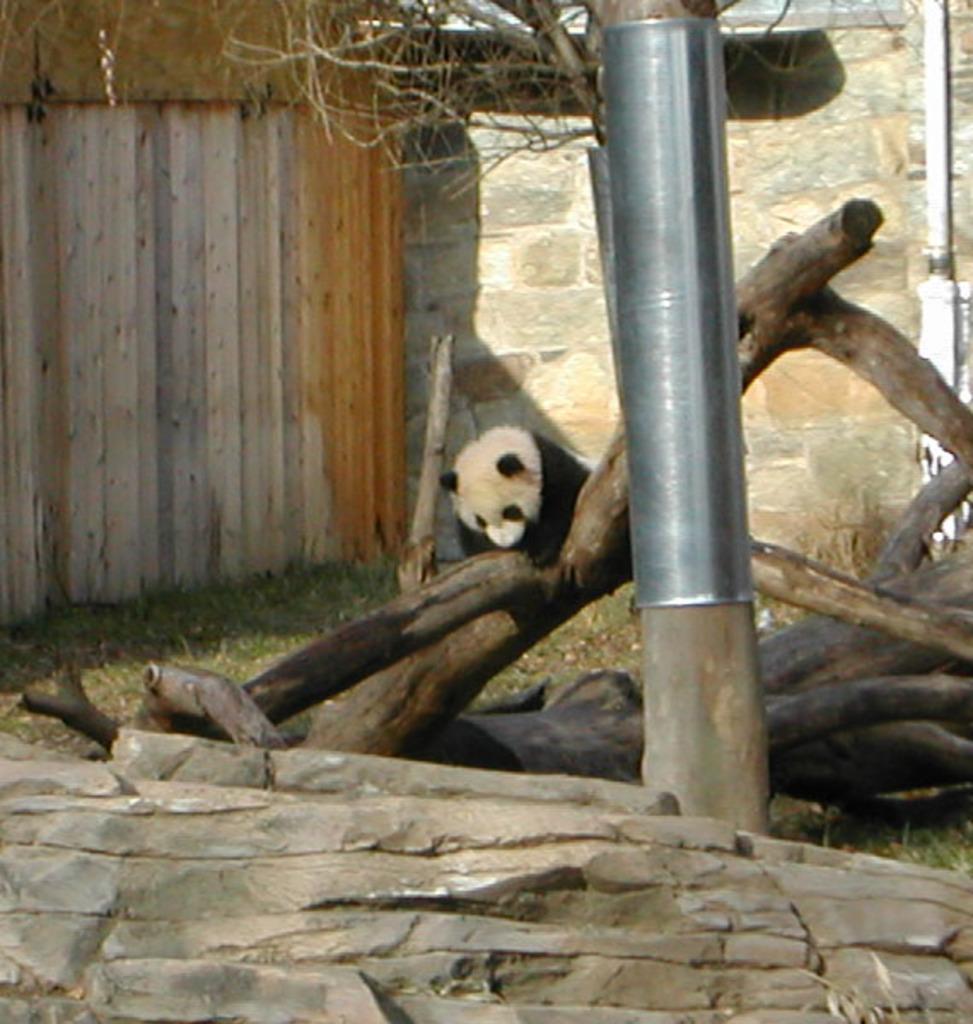Can you describe this image briefly? In this picture we can see a panda, wooden logs, grass, stones and a tree with a metal object on it. In the background we can see the walls. 